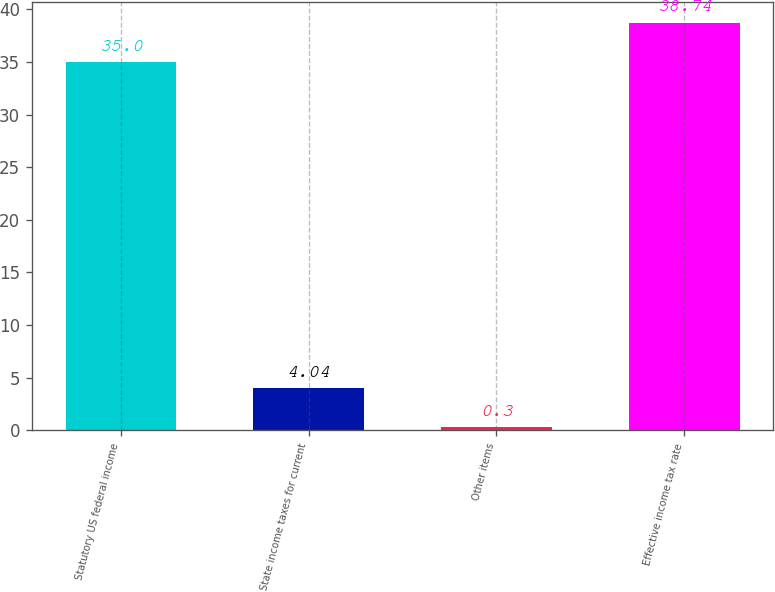<chart> <loc_0><loc_0><loc_500><loc_500><bar_chart><fcel>Statutory US federal income<fcel>State income taxes for current<fcel>Other items<fcel>Effective income tax rate<nl><fcel>35<fcel>4.04<fcel>0.3<fcel>38.74<nl></chart> 